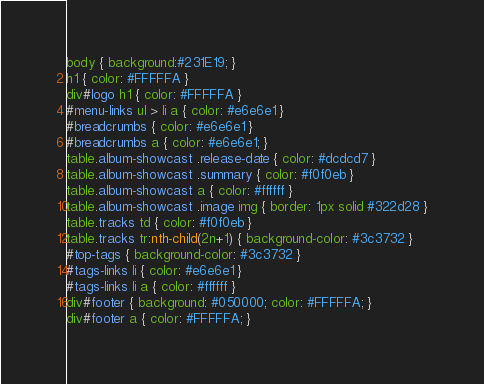Convert code to text. <code><loc_0><loc_0><loc_500><loc_500><_CSS_>
body { background:#231E19; }
h1 { color: #FFFFFA }
div#logo h1 { color: #FFFFFA }
#menu-links ul > li a { color: #e6e6e1 }
#breadcrumbs { color: #e6e6e1 }
#breadcrumbs a { color: #e6e6e1; }
table.album-showcast .release-date { color: #dcdcd7 }
table.album-showcast .summary { color: #f0f0eb }
table.album-showcast a { color: #ffffff }
table.album-showcast .image img { border: 1px solid #322d28 }
table.tracks td { color: #f0f0eb }
table.tracks tr:nth-child(2n+1) { background-color: #3c3732 }
#top-tags { background-color: #3c3732 }
#tags-links li { color: #e6e6e1 }
#tags-links li a { color: #ffffff }
div#footer { background: #050000; color: #FFFFFA; }
div#footer a { color: #FFFFFA; }
</code> 